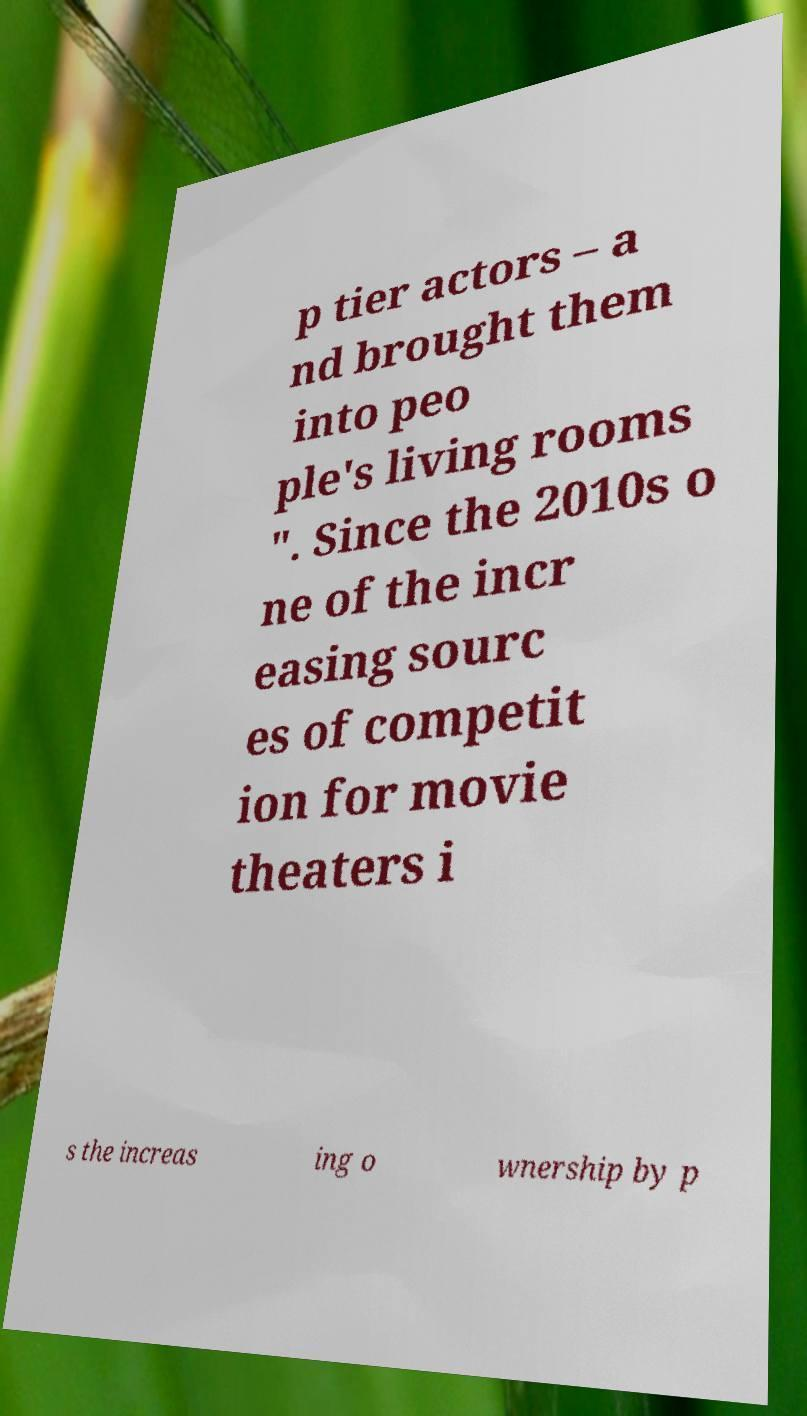For documentation purposes, I need the text within this image transcribed. Could you provide that? p tier actors – a nd brought them into peo ple's living rooms ". Since the 2010s o ne of the incr easing sourc es of competit ion for movie theaters i s the increas ing o wnership by p 